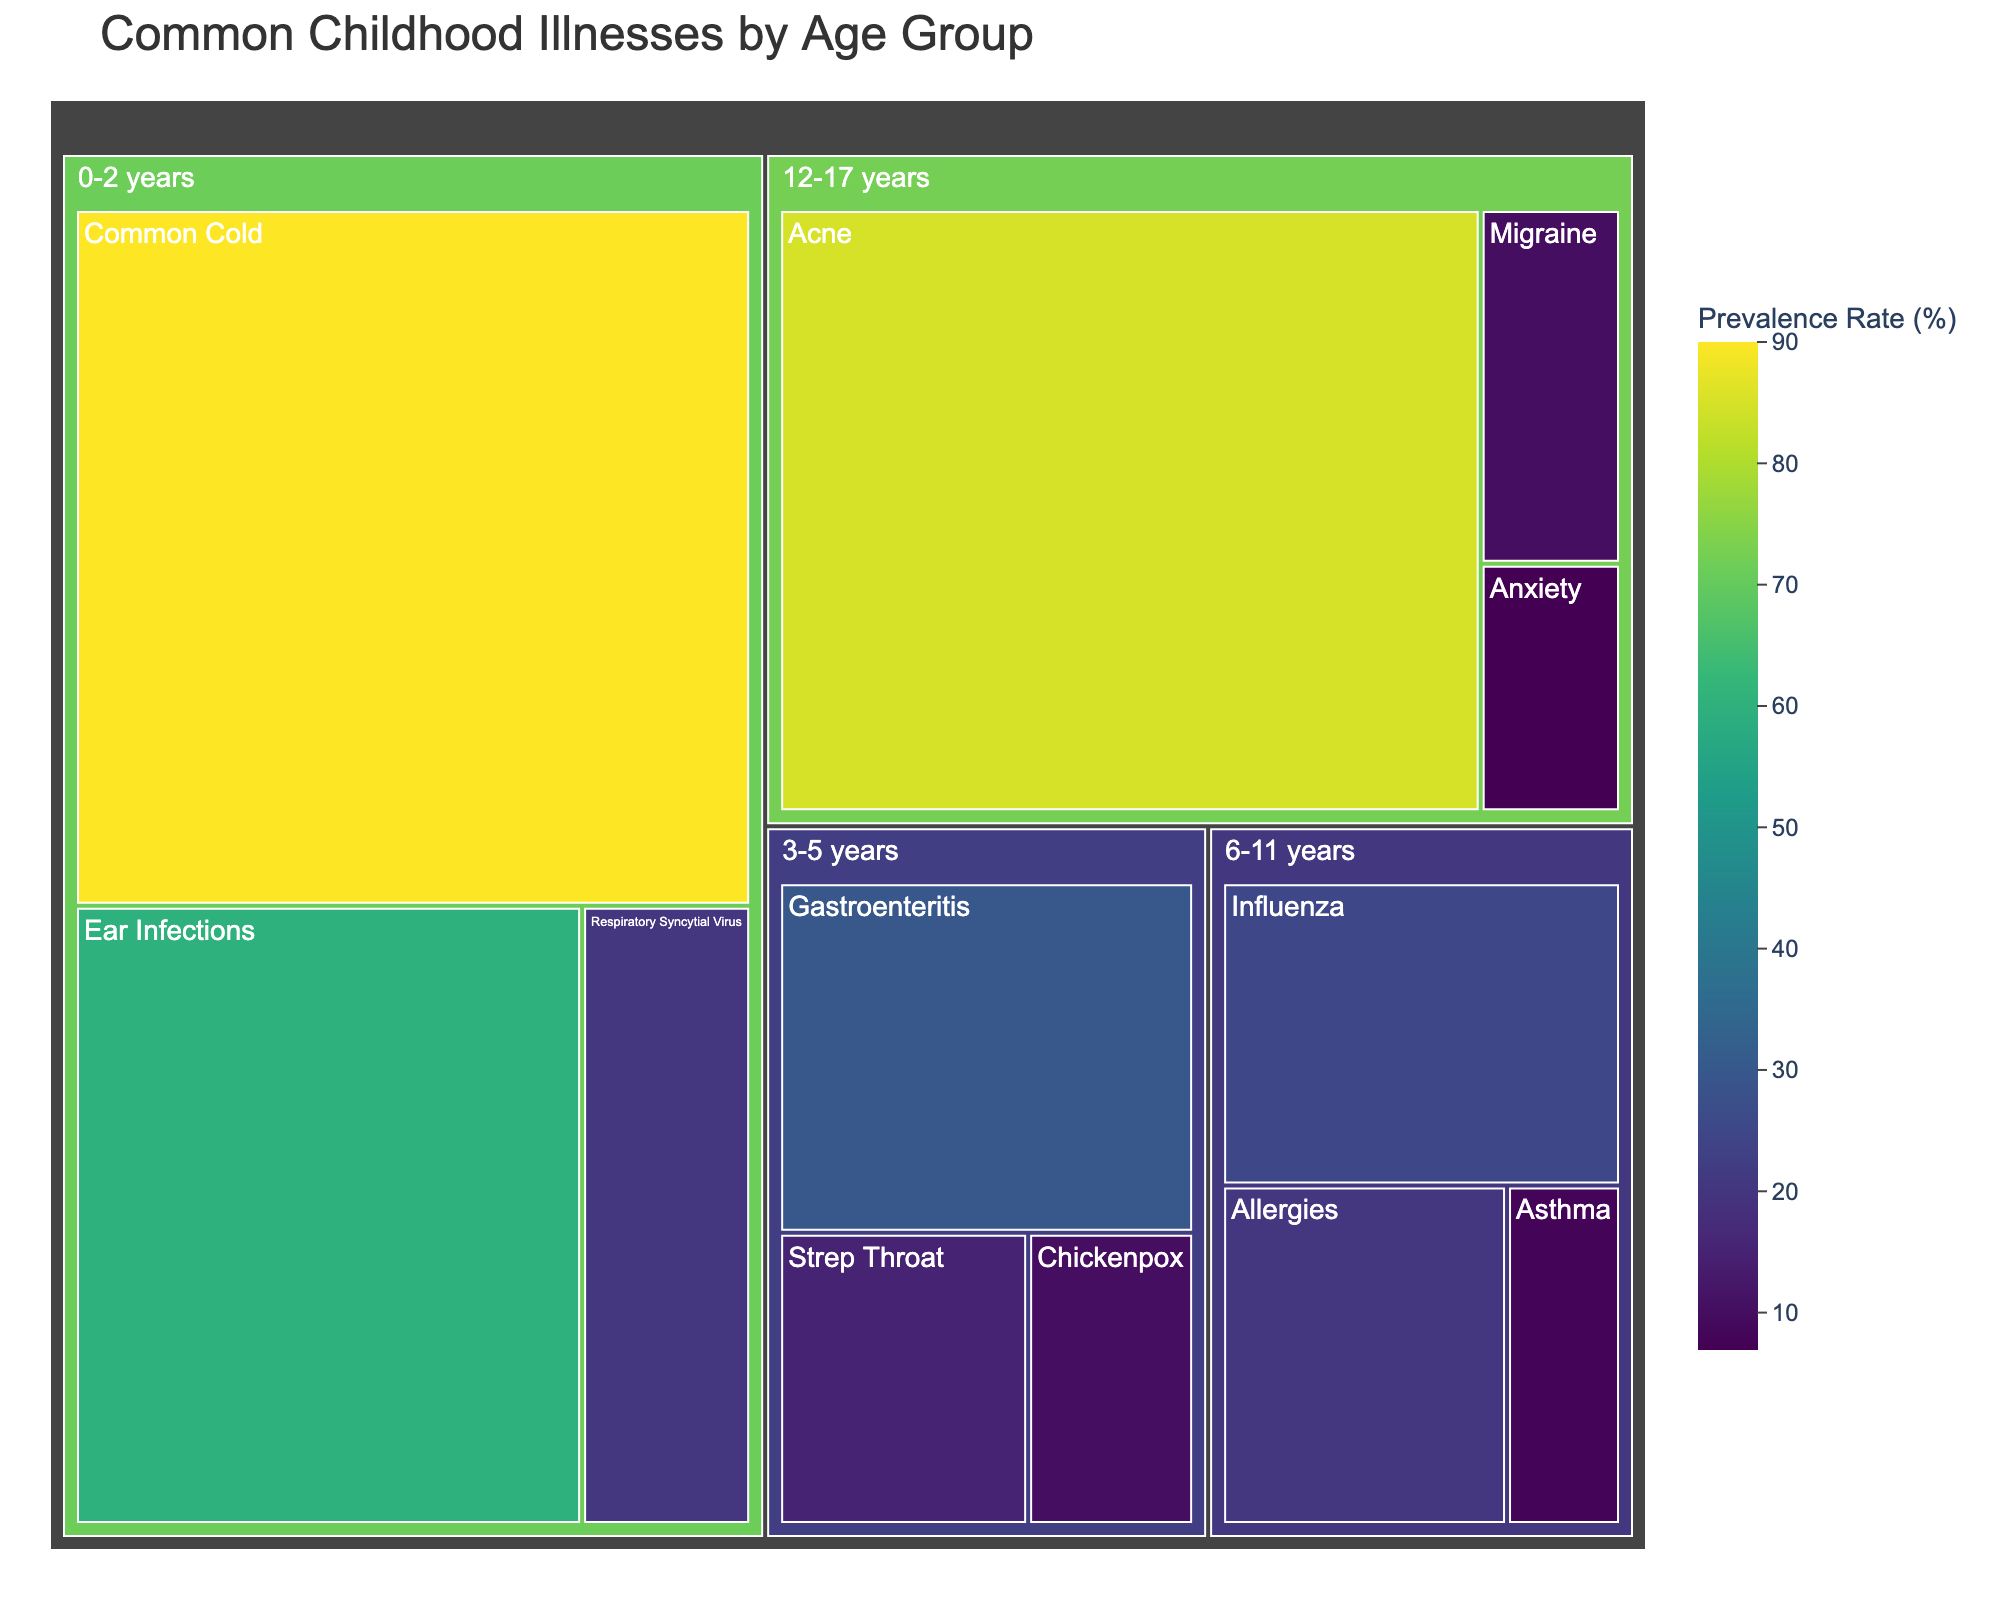What's the title of the treemap? The title is usually placed prominently at the top of the chart. In our case, the chart title is 'Common Childhood Illnesses by Age Group'.
Answer: Common Childhood Illnesses by Age Group Which age group has the highest prevalence of Common Cold? You need to look at the relative size and the color of the boxes representing Common Cold in each age group. The largest and most prominently colored box for Common Cold occurs in the 0-2 years age group.
Answer: 0-2 years How many illnesses are mapped in the 3-5 years age group? Count the individual boxes within the 3-5 years age group section. The illnesses in this age group are Strep Throat, Chickenpox, and Gastroenteritis.
Answer: 3 What's the prevalence rate of Acne in the 12-17 years age group? Locate the 12-17 years age group section and then look for the box representing Acne. The prevalence rate is written within or near the box.
Answer: 85% Which illness has the lowest prevalence rate in the 6-11 years age group? In the 6-11 years age group section, compare the sizes and color shades of the boxes. The smallest and least prominently colored one corresponds to the illness with the lowest prevalence, which is Asthma.
Answer: Asthma What is the combined prevalence rate of Chickenpox in the 3-5 years age group and Anxiety in the 12-17 years age group? Identify the prevalence rates for Chickenpox (10%) and Anxiety (7%). Add these percentages together to get the combined rate.
Answer: 17% How does the prevalence of Ear Infections in the 0-2 years age group compare to Allergies in the 6-11 years age group? Look at the prevalence rate for Ear Infections (60%) and compare it to that of Allergies (20%). Ear Infections is significantly higher than Allergies.
Answer: Ear Infections is higher Which illness has a greater prevalence rate: Respiratory Syncytial Virus in the 0-2 years age group or Influenza in the 6-11 years age group? Find the prevalence rates for Respiratory Syncytial Virus (20%) and Influenza (25%). Influenza has a higher prevalence rate.
Answer: Influenza What is the total number of age groups represented in the treemap? Age groups are usually represented by higher-level rectangles clustering multiple illnesses. Count these groups to get the total number.
Answer: 4 What's the color scheme used to represent the prevalence rate, and how is it applied? The color scheme used is 'Viridis', a range of colors from yellow to greenish-blue to dark blue, where lighter colors indicate higher prevalence rates and darker colors indicate lower rates.
Answer: Viridis color scale 